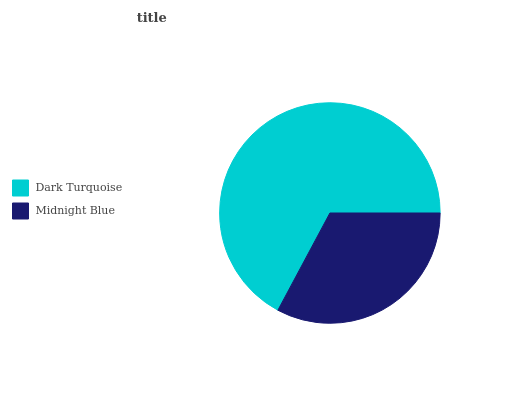Is Midnight Blue the minimum?
Answer yes or no. Yes. Is Dark Turquoise the maximum?
Answer yes or no. Yes. Is Midnight Blue the maximum?
Answer yes or no. No. Is Dark Turquoise greater than Midnight Blue?
Answer yes or no. Yes. Is Midnight Blue less than Dark Turquoise?
Answer yes or no. Yes. Is Midnight Blue greater than Dark Turquoise?
Answer yes or no. No. Is Dark Turquoise less than Midnight Blue?
Answer yes or no. No. Is Dark Turquoise the high median?
Answer yes or no. Yes. Is Midnight Blue the low median?
Answer yes or no. Yes. Is Midnight Blue the high median?
Answer yes or no. No. Is Dark Turquoise the low median?
Answer yes or no. No. 